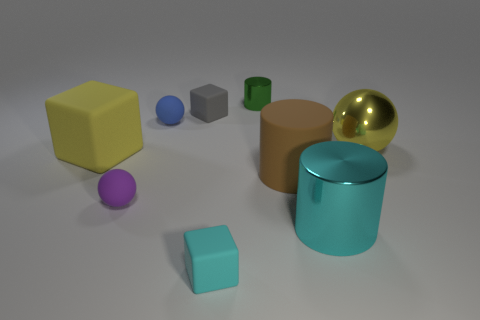Subtract 1 spheres. How many spheres are left? 2 Add 1 yellow metallic blocks. How many objects exist? 10 Subtract all spheres. How many objects are left? 6 Add 7 small gray matte things. How many small gray matte things are left? 8 Add 8 gray rubber things. How many gray rubber things exist? 9 Subtract 0 purple cylinders. How many objects are left? 9 Subtract all small purple objects. Subtract all large yellow balls. How many objects are left? 7 